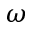<formula> <loc_0><loc_0><loc_500><loc_500>\omega</formula> 